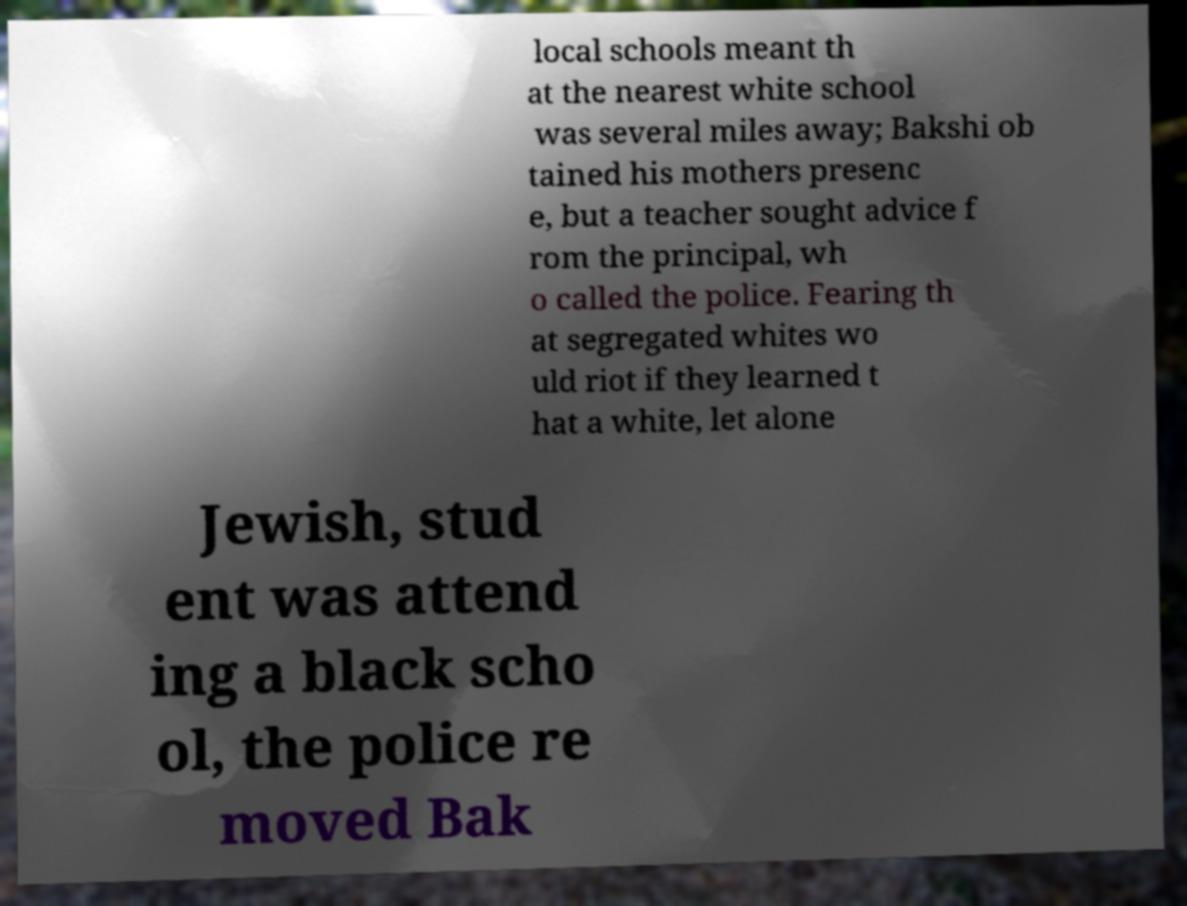What messages or text are displayed in this image? I need them in a readable, typed format. local schools meant th at the nearest white school was several miles away; Bakshi ob tained his mothers presenc e, but a teacher sought advice f rom the principal, wh o called the police. Fearing th at segregated whites wo uld riot if they learned t hat a white, let alone Jewish, stud ent was attend ing a black scho ol, the police re moved Bak 